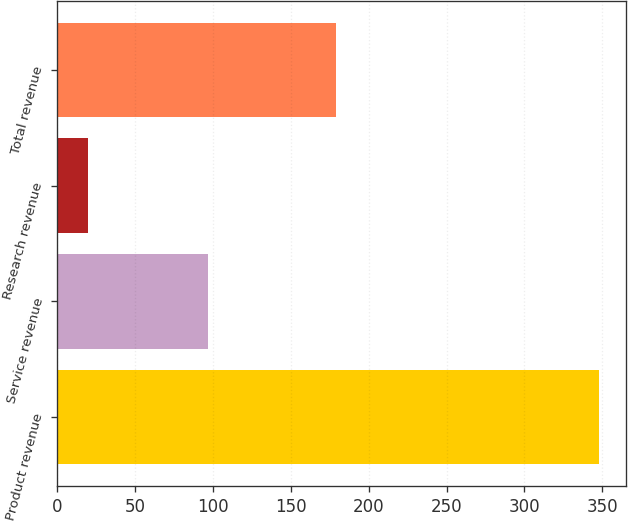<chart> <loc_0><loc_0><loc_500><loc_500><bar_chart><fcel>Product revenue<fcel>Service revenue<fcel>Research revenue<fcel>Total revenue<nl><fcel>348<fcel>97<fcel>20<fcel>179<nl></chart> 